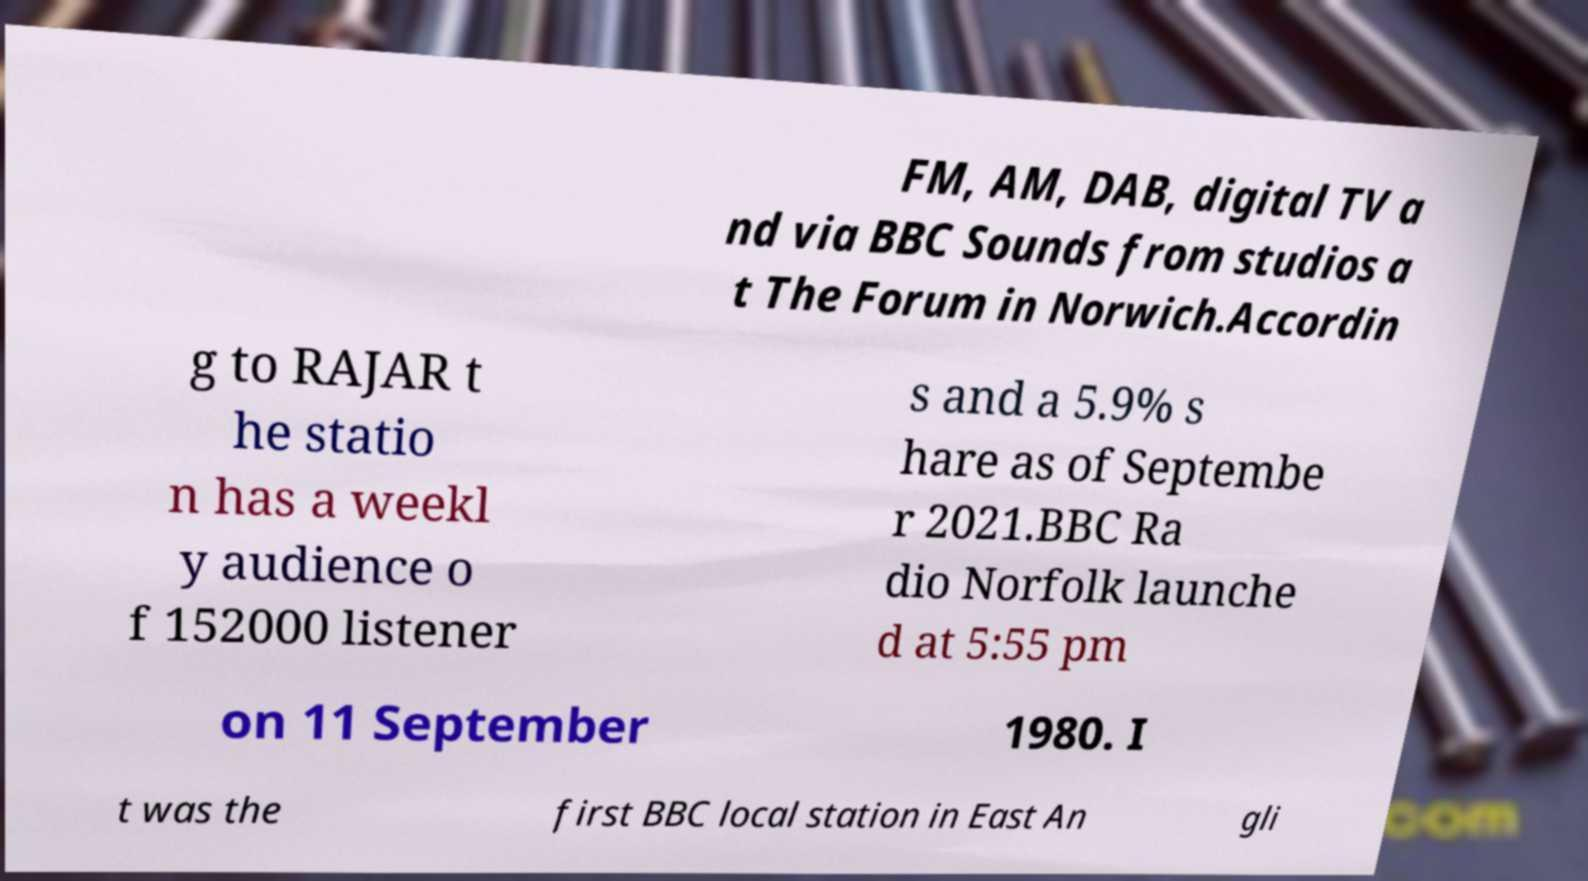Can you accurately transcribe the text from the provided image for me? FM, AM, DAB, digital TV a nd via BBC Sounds from studios a t The Forum in Norwich.Accordin g to RAJAR t he statio n has a weekl y audience o f 152000 listener s and a 5.9% s hare as of Septembe r 2021.BBC Ra dio Norfolk launche d at 5:55 pm on 11 September 1980. I t was the first BBC local station in East An gli 